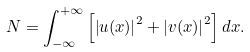<formula> <loc_0><loc_0><loc_500><loc_500>N = \int _ { - \infty } ^ { + \infty } \left [ \left | u ( x ) \right | ^ { 2 } + \left | v ( x ) \right | ^ { 2 } \right ] d x .</formula> 